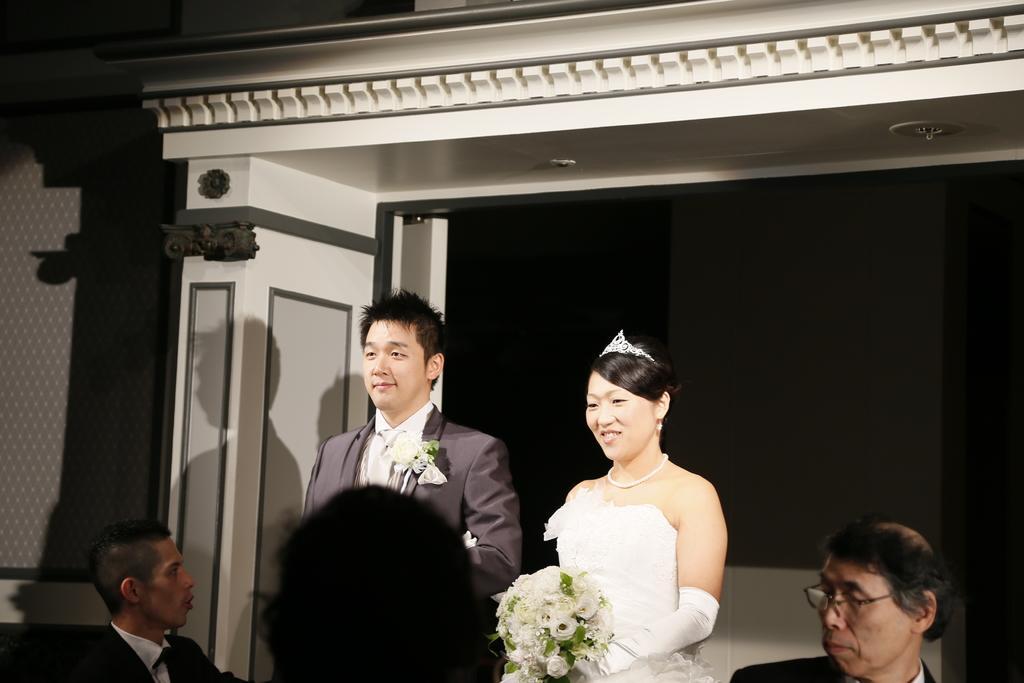Describe this image in one or two sentences. In the image we can see there are people standing, wearing clothes and two of them are smiling. Here we can see the woman wearing a neck chain, earrings, the crown and she is holding flower bouquet in her hand. The background is slightly dark. 